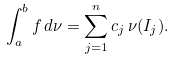Convert formula to latex. <formula><loc_0><loc_0><loc_500><loc_500>\int _ { a } ^ { b } f \, d \nu = \sum _ { j = 1 } ^ { n } c _ { j } \, \nu ( I _ { j } ) .</formula> 